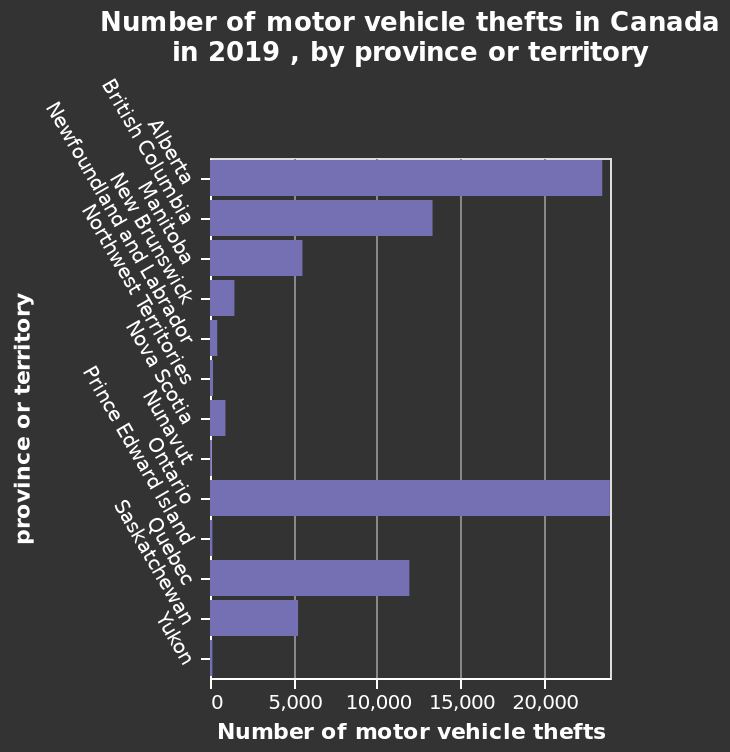<image>
Which province or territory in Canada had the highest number of motor vehicle thefts in 2019? The province or territory with the highest number of motor vehicle thefts in Canada in 2019 is not specified in the given description. Are there any significant differences in the number of motor vehicle thefts among the provinces or territories in Canada in 2019? The significant differences in the number of motor vehicle thefts among the provinces or territories in Canada in 2019 are not specified in the given description. Describe the following image in detail Number of motor vehicle thefts in Canada in 2019 , by province or territory is a bar graph. The y-axis plots province or territory while the x-axis plots Number of motor vehicle thefts. Which territories had the lowest number of stolen vehicles in 2019? Yukon, Prince Edward Island, and Nunavut had the lowest number of stolen vehicles in 2019. Can you provide the exact number of motor vehicle thefts for each province or territory in Canada in 2019? The exact number of motor vehicle thefts for each province or territory in Canada in 2019 is not provided in the given description. 